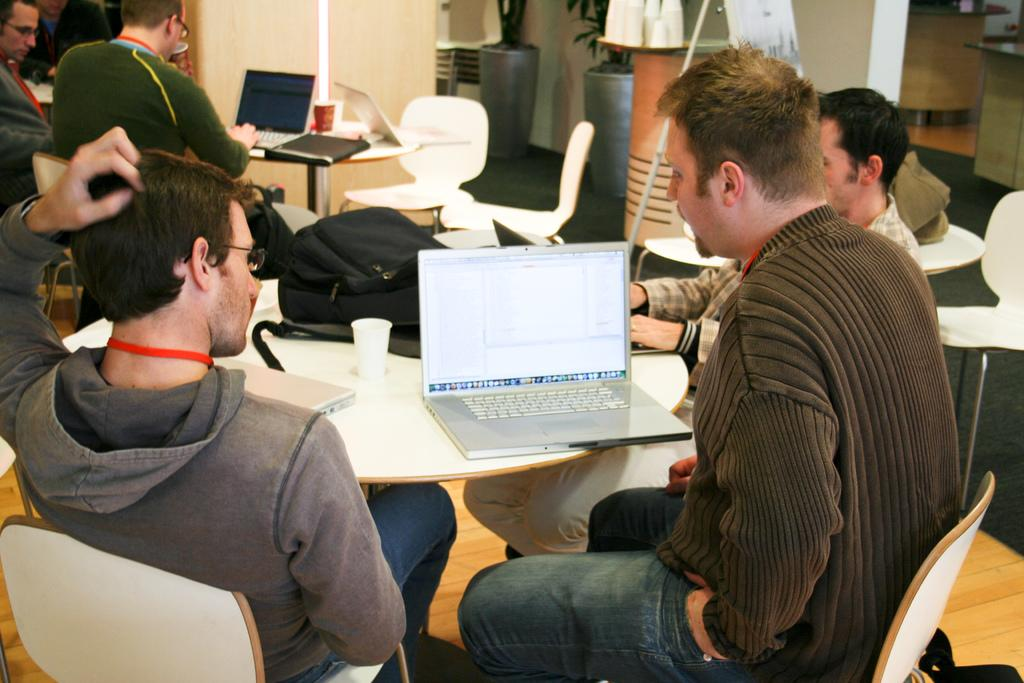What are the men in the image doing? The men are sitting in a room and operating laptops. Where are the men located in relation to the table? The men are in front of the table. What items can be seen on the table? There are backpacks on the table. What type of alarm can be heard in the image? There is no alarm present in the image; it only shows men sitting in a room and operating laptops. 